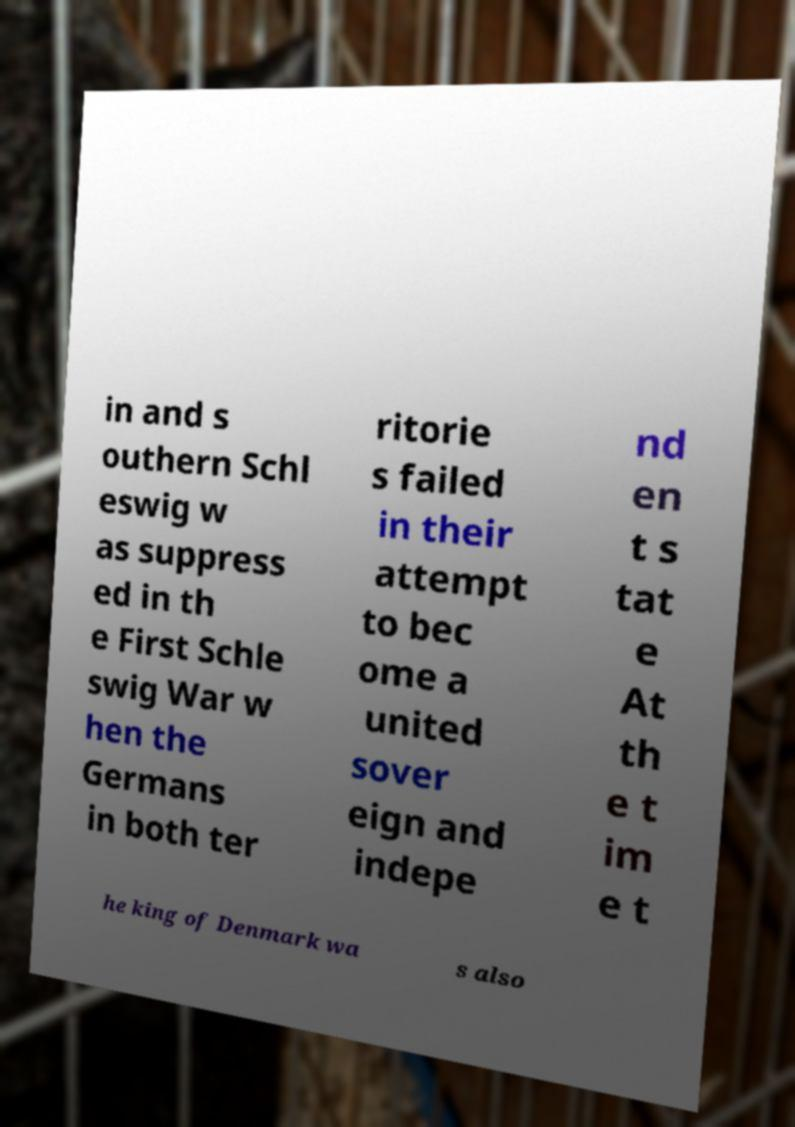Could you extract and type out the text from this image? in and s outhern Schl eswig w as suppress ed in th e First Schle swig War w hen the Germans in both ter ritorie s failed in their attempt to bec ome a united sover eign and indepe nd en t s tat e At th e t im e t he king of Denmark wa s also 